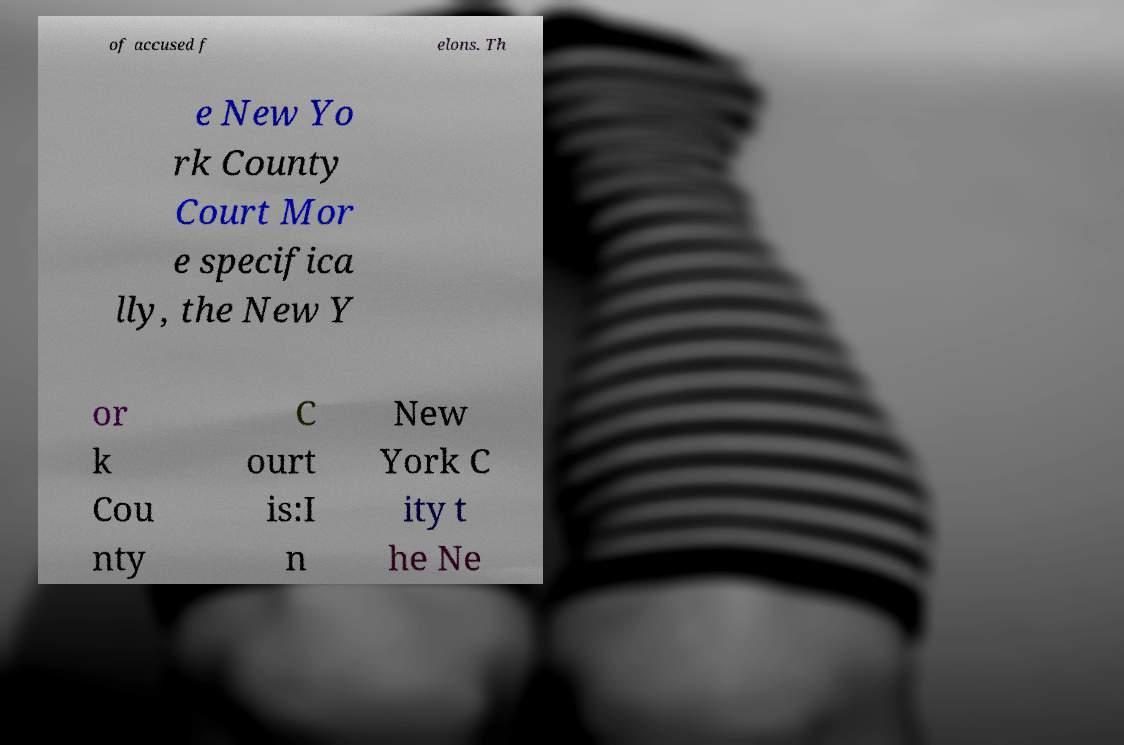There's text embedded in this image that I need extracted. Can you transcribe it verbatim? of accused f elons. Th e New Yo rk County Court Mor e specifica lly, the New Y or k Cou nty C ourt is:I n New York C ity t he Ne 